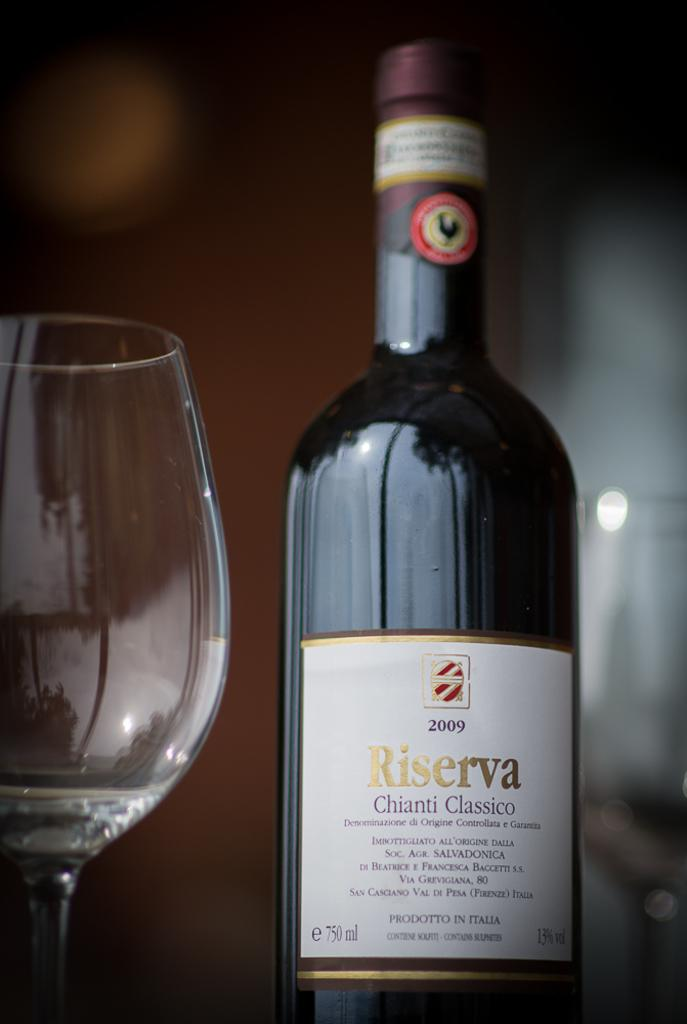<image>
Provide a brief description of the given image. A bottle of Riserva Chianti Classico from 2009. 